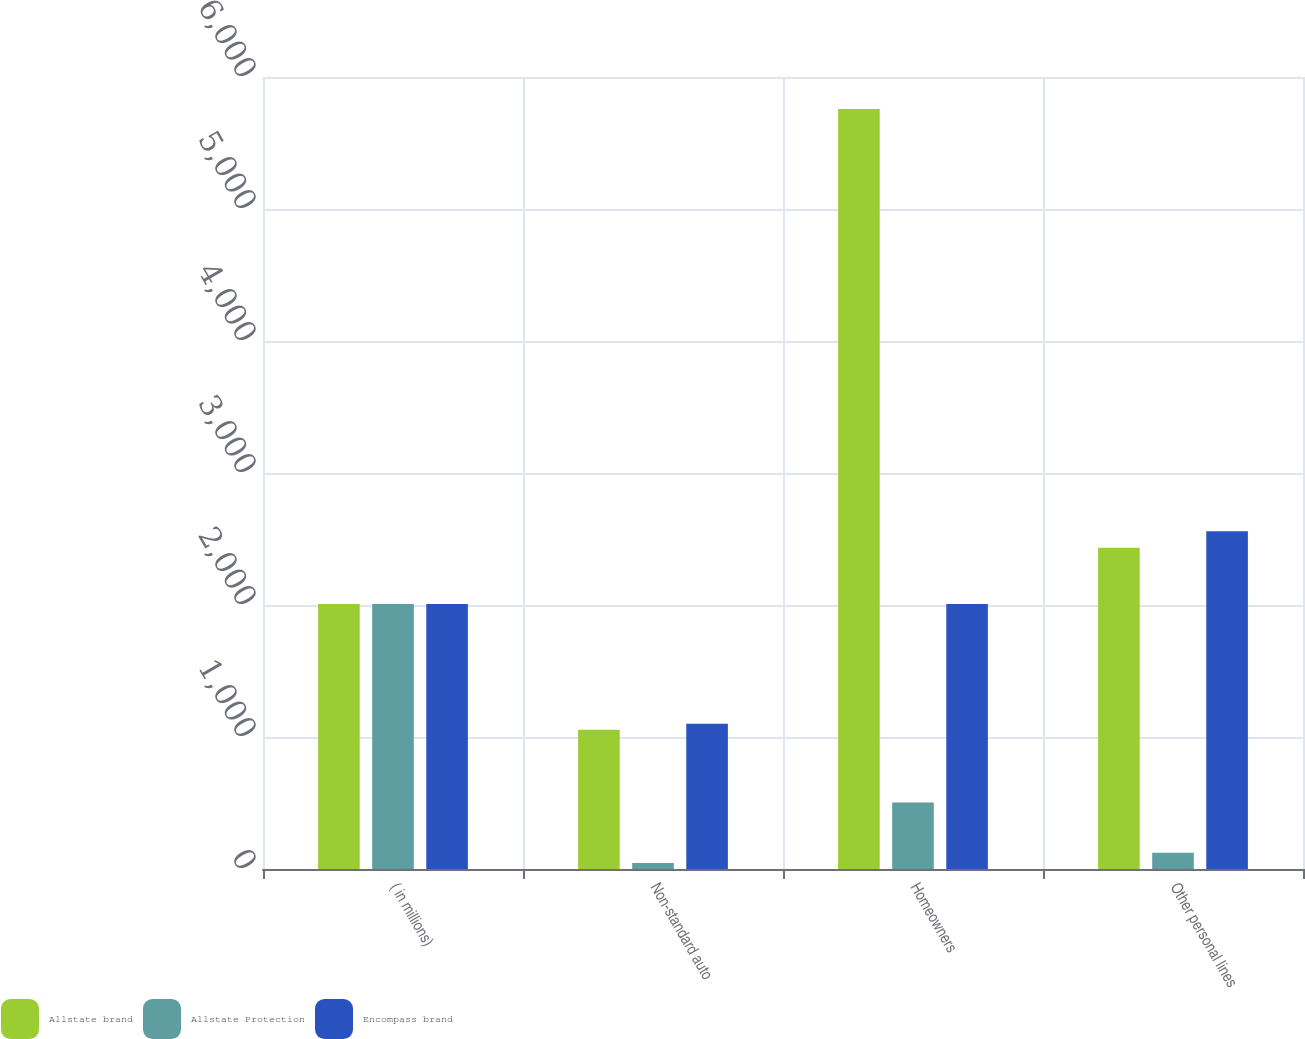<chart> <loc_0><loc_0><loc_500><loc_500><stacked_bar_chart><ecel><fcel>( in millions)<fcel>Non-standard auto<fcel>Homeowners<fcel>Other personal lines<nl><fcel>Allstate brand<fcel>2008<fcel>1055<fcel>5758<fcel>2434<nl><fcel>Allstate Protection<fcel>2008<fcel>45<fcel>503<fcel>124<nl><fcel>Encompass brand<fcel>2008<fcel>1100<fcel>2008<fcel>2558<nl></chart> 